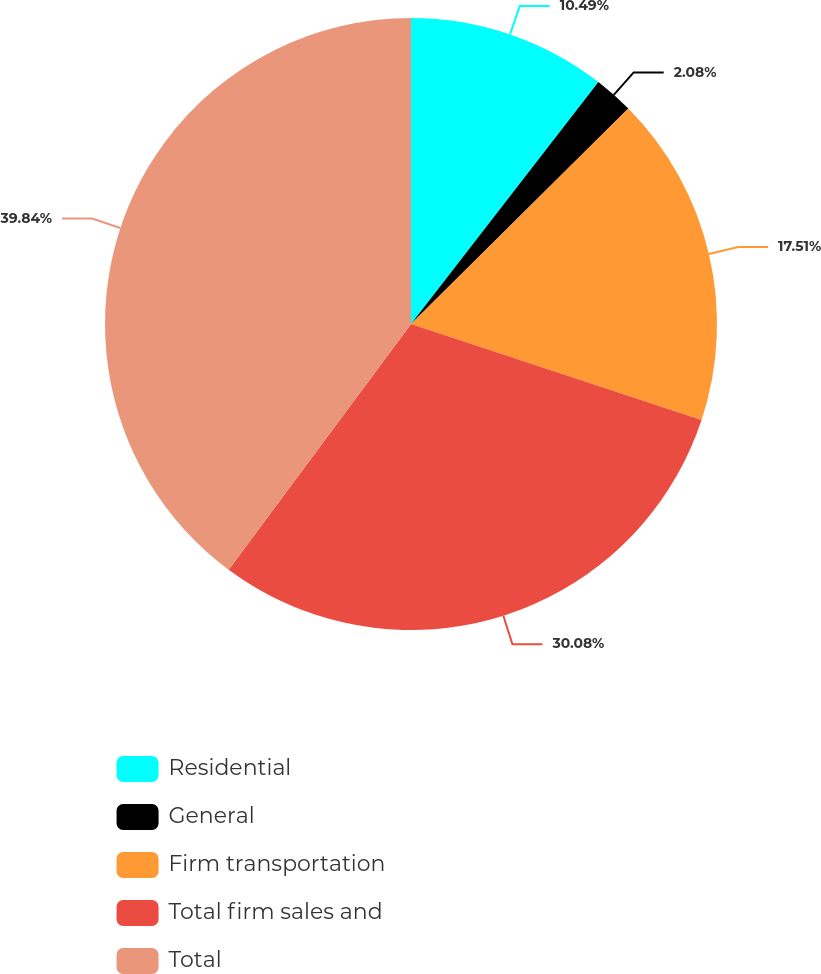Convert chart to OTSL. <chart><loc_0><loc_0><loc_500><loc_500><pie_chart><fcel>Residential<fcel>General<fcel>Firm transportation<fcel>Total firm sales and<fcel>Total<nl><fcel>10.49%<fcel>2.08%<fcel>17.51%<fcel>30.08%<fcel>39.84%<nl></chart> 